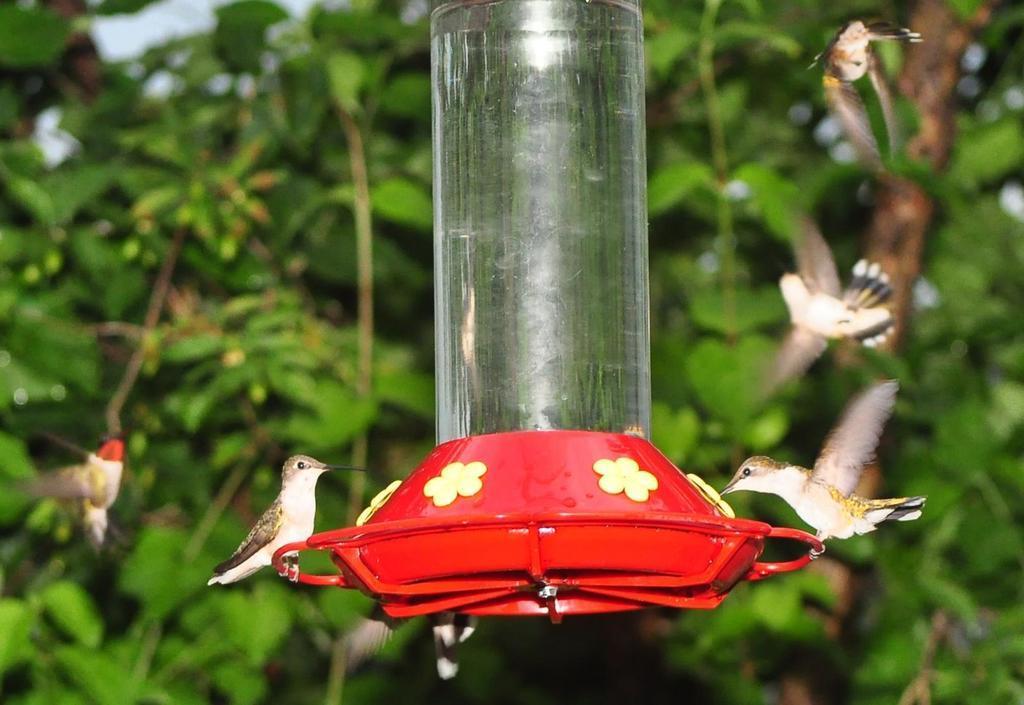How would you summarize this image in a sentence or two? This image consists of small birds. In the middle, we can see the water in the container. In the background, there are trees. 